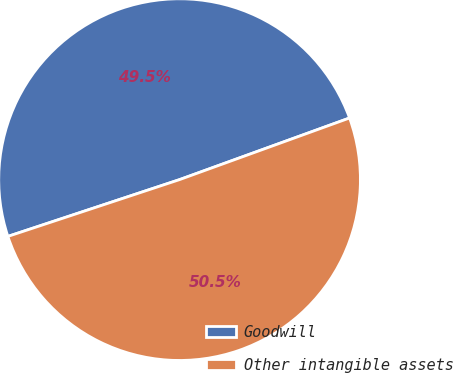Convert chart to OTSL. <chart><loc_0><loc_0><loc_500><loc_500><pie_chart><fcel>Goodwill<fcel>Other intangible assets<nl><fcel>49.55%<fcel>50.45%<nl></chart> 